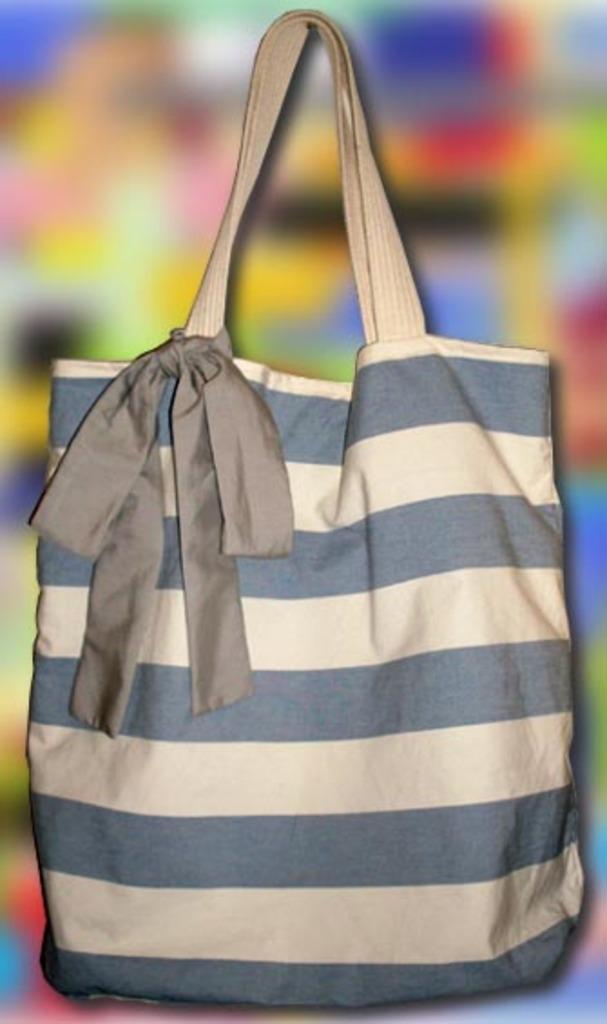Could you give a brief overview of what you see in this image? There is a bag and it is in the combination of grey and white colors with horizontal lines. And there is a ribbon. 